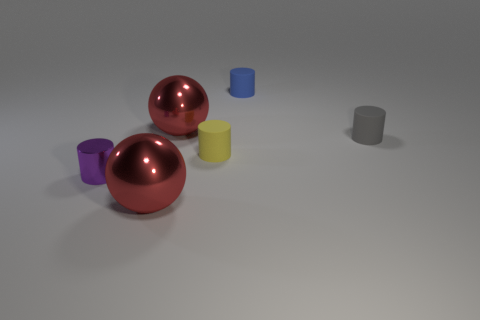Are there fewer rubber cylinders that are in front of the purple thing than big balls that are in front of the small gray rubber cylinder?
Give a very brief answer. Yes. What number of large things are red shiny spheres or shiny cylinders?
Give a very brief answer. 2. There is a big red metal thing in front of the tiny metallic cylinder; is its shape the same as the small blue matte thing that is behind the gray rubber object?
Your answer should be very brief. No. How big is the rubber thing to the left of the matte cylinder that is behind the cylinder on the right side of the tiny blue object?
Ensure brevity in your answer.  Small. There is a red metal object that is behind the purple shiny object; what is its size?
Make the answer very short. Large. What is the red sphere behind the tiny yellow rubber cylinder made of?
Your answer should be compact. Metal. What number of yellow objects are either big metallic balls or cylinders?
Keep it short and to the point. 1. Is the blue cylinder made of the same material as the large red thing that is in front of the purple shiny thing?
Make the answer very short. No. Are there the same number of big objects that are to the right of the yellow object and big red metal objects in front of the gray cylinder?
Provide a short and direct response. No. There is a gray cylinder; does it have the same size as the matte cylinder on the left side of the small blue cylinder?
Offer a very short reply. Yes. 